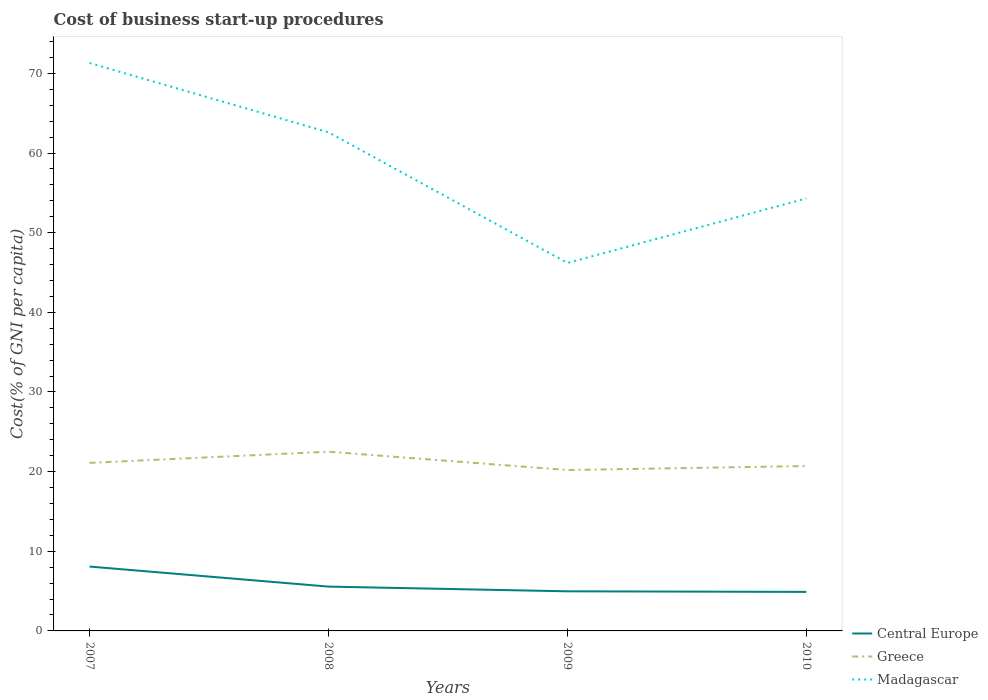Does the line corresponding to Greece intersect with the line corresponding to Madagascar?
Offer a very short reply. No. Across all years, what is the maximum cost of business start-up procedures in Central Europe?
Offer a terse response. 4.9. In which year was the cost of business start-up procedures in Madagascar maximum?
Give a very brief answer. 2009. What is the total cost of business start-up procedures in Greece in the graph?
Make the answer very short. 0.4. What is the difference between the highest and the second highest cost of business start-up procedures in Madagascar?
Keep it short and to the point. 25.1. What is the difference between the highest and the lowest cost of business start-up procedures in Central Europe?
Your answer should be very brief. 1. Is the cost of business start-up procedures in Greece strictly greater than the cost of business start-up procedures in Central Europe over the years?
Offer a terse response. No. How many years are there in the graph?
Provide a succinct answer. 4. How are the legend labels stacked?
Keep it short and to the point. Vertical. What is the title of the graph?
Keep it short and to the point. Cost of business start-up procedures. What is the label or title of the X-axis?
Offer a terse response. Years. What is the label or title of the Y-axis?
Provide a short and direct response. Cost(% of GNI per capita). What is the Cost(% of GNI per capita) of Central Europe in 2007?
Your response must be concise. 8.08. What is the Cost(% of GNI per capita) of Greece in 2007?
Offer a terse response. 21.1. What is the Cost(% of GNI per capita) of Madagascar in 2007?
Provide a succinct answer. 71.3. What is the Cost(% of GNI per capita) of Central Europe in 2008?
Keep it short and to the point. 5.56. What is the Cost(% of GNI per capita) in Madagascar in 2008?
Ensure brevity in your answer.  62.6. What is the Cost(% of GNI per capita) of Central Europe in 2009?
Ensure brevity in your answer.  4.97. What is the Cost(% of GNI per capita) of Greece in 2009?
Offer a terse response. 20.2. What is the Cost(% of GNI per capita) in Madagascar in 2009?
Your response must be concise. 46.2. What is the Cost(% of GNI per capita) in Central Europe in 2010?
Your response must be concise. 4.9. What is the Cost(% of GNI per capita) in Greece in 2010?
Provide a succinct answer. 20.7. What is the Cost(% of GNI per capita) in Madagascar in 2010?
Provide a short and direct response. 54.3. Across all years, what is the maximum Cost(% of GNI per capita) in Central Europe?
Your response must be concise. 8.08. Across all years, what is the maximum Cost(% of GNI per capita) of Madagascar?
Give a very brief answer. 71.3. Across all years, what is the minimum Cost(% of GNI per capita) of Greece?
Offer a terse response. 20.2. Across all years, what is the minimum Cost(% of GNI per capita) of Madagascar?
Provide a short and direct response. 46.2. What is the total Cost(% of GNI per capita) of Central Europe in the graph?
Offer a very short reply. 23.52. What is the total Cost(% of GNI per capita) in Greece in the graph?
Ensure brevity in your answer.  84.5. What is the total Cost(% of GNI per capita) of Madagascar in the graph?
Ensure brevity in your answer.  234.4. What is the difference between the Cost(% of GNI per capita) in Central Europe in 2007 and that in 2008?
Make the answer very short. 2.52. What is the difference between the Cost(% of GNI per capita) in Greece in 2007 and that in 2008?
Give a very brief answer. -1.4. What is the difference between the Cost(% of GNI per capita) in Central Europe in 2007 and that in 2009?
Ensure brevity in your answer.  3.11. What is the difference between the Cost(% of GNI per capita) of Greece in 2007 and that in 2009?
Offer a terse response. 0.9. What is the difference between the Cost(% of GNI per capita) of Madagascar in 2007 and that in 2009?
Offer a terse response. 25.1. What is the difference between the Cost(% of GNI per capita) of Central Europe in 2007 and that in 2010?
Offer a terse response. 3.18. What is the difference between the Cost(% of GNI per capita) of Madagascar in 2007 and that in 2010?
Your answer should be very brief. 17. What is the difference between the Cost(% of GNI per capita) of Central Europe in 2008 and that in 2009?
Your response must be concise. 0.59. What is the difference between the Cost(% of GNI per capita) of Greece in 2008 and that in 2009?
Offer a very short reply. 2.3. What is the difference between the Cost(% of GNI per capita) of Madagascar in 2008 and that in 2009?
Keep it short and to the point. 16.4. What is the difference between the Cost(% of GNI per capita) in Central Europe in 2008 and that in 2010?
Give a very brief answer. 0.66. What is the difference between the Cost(% of GNI per capita) of Central Europe in 2009 and that in 2010?
Give a very brief answer. 0.07. What is the difference between the Cost(% of GNI per capita) of Madagascar in 2009 and that in 2010?
Give a very brief answer. -8.1. What is the difference between the Cost(% of GNI per capita) of Central Europe in 2007 and the Cost(% of GNI per capita) of Greece in 2008?
Your answer should be very brief. -14.42. What is the difference between the Cost(% of GNI per capita) in Central Europe in 2007 and the Cost(% of GNI per capita) in Madagascar in 2008?
Offer a terse response. -54.52. What is the difference between the Cost(% of GNI per capita) of Greece in 2007 and the Cost(% of GNI per capita) of Madagascar in 2008?
Keep it short and to the point. -41.5. What is the difference between the Cost(% of GNI per capita) in Central Europe in 2007 and the Cost(% of GNI per capita) in Greece in 2009?
Give a very brief answer. -12.12. What is the difference between the Cost(% of GNI per capita) of Central Europe in 2007 and the Cost(% of GNI per capita) of Madagascar in 2009?
Ensure brevity in your answer.  -38.12. What is the difference between the Cost(% of GNI per capita) in Greece in 2007 and the Cost(% of GNI per capita) in Madagascar in 2009?
Make the answer very short. -25.1. What is the difference between the Cost(% of GNI per capita) in Central Europe in 2007 and the Cost(% of GNI per capita) in Greece in 2010?
Your answer should be compact. -12.62. What is the difference between the Cost(% of GNI per capita) of Central Europe in 2007 and the Cost(% of GNI per capita) of Madagascar in 2010?
Provide a succinct answer. -46.22. What is the difference between the Cost(% of GNI per capita) of Greece in 2007 and the Cost(% of GNI per capita) of Madagascar in 2010?
Offer a terse response. -33.2. What is the difference between the Cost(% of GNI per capita) in Central Europe in 2008 and the Cost(% of GNI per capita) in Greece in 2009?
Your answer should be compact. -14.64. What is the difference between the Cost(% of GNI per capita) in Central Europe in 2008 and the Cost(% of GNI per capita) in Madagascar in 2009?
Provide a short and direct response. -40.64. What is the difference between the Cost(% of GNI per capita) of Greece in 2008 and the Cost(% of GNI per capita) of Madagascar in 2009?
Keep it short and to the point. -23.7. What is the difference between the Cost(% of GNI per capita) in Central Europe in 2008 and the Cost(% of GNI per capita) in Greece in 2010?
Your answer should be compact. -15.14. What is the difference between the Cost(% of GNI per capita) in Central Europe in 2008 and the Cost(% of GNI per capita) in Madagascar in 2010?
Your answer should be compact. -48.74. What is the difference between the Cost(% of GNI per capita) in Greece in 2008 and the Cost(% of GNI per capita) in Madagascar in 2010?
Offer a terse response. -31.8. What is the difference between the Cost(% of GNI per capita) in Central Europe in 2009 and the Cost(% of GNI per capita) in Greece in 2010?
Your answer should be compact. -15.73. What is the difference between the Cost(% of GNI per capita) in Central Europe in 2009 and the Cost(% of GNI per capita) in Madagascar in 2010?
Make the answer very short. -49.33. What is the difference between the Cost(% of GNI per capita) in Greece in 2009 and the Cost(% of GNI per capita) in Madagascar in 2010?
Provide a succinct answer. -34.1. What is the average Cost(% of GNI per capita) of Central Europe per year?
Offer a terse response. 5.88. What is the average Cost(% of GNI per capita) in Greece per year?
Offer a terse response. 21.12. What is the average Cost(% of GNI per capita) in Madagascar per year?
Your response must be concise. 58.6. In the year 2007, what is the difference between the Cost(% of GNI per capita) of Central Europe and Cost(% of GNI per capita) of Greece?
Offer a terse response. -13.02. In the year 2007, what is the difference between the Cost(% of GNI per capita) in Central Europe and Cost(% of GNI per capita) in Madagascar?
Offer a very short reply. -63.22. In the year 2007, what is the difference between the Cost(% of GNI per capita) of Greece and Cost(% of GNI per capita) of Madagascar?
Offer a terse response. -50.2. In the year 2008, what is the difference between the Cost(% of GNI per capita) in Central Europe and Cost(% of GNI per capita) in Greece?
Make the answer very short. -16.94. In the year 2008, what is the difference between the Cost(% of GNI per capita) in Central Europe and Cost(% of GNI per capita) in Madagascar?
Ensure brevity in your answer.  -57.04. In the year 2008, what is the difference between the Cost(% of GNI per capita) in Greece and Cost(% of GNI per capita) in Madagascar?
Give a very brief answer. -40.1. In the year 2009, what is the difference between the Cost(% of GNI per capita) of Central Europe and Cost(% of GNI per capita) of Greece?
Your response must be concise. -15.23. In the year 2009, what is the difference between the Cost(% of GNI per capita) of Central Europe and Cost(% of GNI per capita) of Madagascar?
Make the answer very short. -41.23. In the year 2009, what is the difference between the Cost(% of GNI per capita) of Greece and Cost(% of GNI per capita) of Madagascar?
Your answer should be compact. -26. In the year 2010, what is the difference between the Cost(% of GNI per capita) in Central Europe and Cost(% of GNI per capita) in Greece?
Offer a terse response. -15.8. In the year 2010, what is the difference between the Cost(% of GNI per capita) in Central Europe and Cost(% of GNI per capita) in Madagascar?
Your answer should be compact. -49.4. In the year 2010, what is the difference between the Cost(% of GNI per capita) in Greece and Cost(% of GNI per capita) in Madagascar?
Offer a terse response. -33.6. What is the ratio of the Cost(% of GNI per capita) of Central Europe in 2007 to that in 2008?
Provide a short and direct response. 1.45. What is the ratio of the Cost(% of GNI per capita) of Greece in 2007 to that in 2008?
Offer a terse response. 0.94. What is the ratio of the Cost(% of GNI per capita) of Madagascar in 2007 to that in 2008?
Your response must be concise. 1.14. What is the ratio of the Cost(% of GNI per capita) of Central Europe in 2007 to that in 2009?
Provide a short and direct response. 1.63. What is the ratio of the Cost(% of GNI per capita) of Greece in 2007 to that in 2009?
Make the answer very short. 1.04. What is the ratio of the Cost(% of GNI per capita) of Madagascar in 2007 to that in 2009?
Offer a terse response. 1.54. What is the ratio of the Cost(% of GNI per capita) in Central Europe in 2007 to that in 2010?
Give a very brief answer. 1.65. What is the ratio of the Cost(% of GNI per capita) of Greece in 2007 to that in 2010?
Ensure brevity in your answer.  1.02. What is the ratio of the Cost(% of GNI per capita) in Madagascar in 2007 to that in 2010?
Offer a very short reply. 1.31. What is the ratio of the Cost(% of GNI per capita) in Central Europe in 2008 to that in 2009?
Offer a terse response. 1.12. What is the ratio of the Cost(% of GNI per capita) in Greece in 2008 to that in 2009?
Your response must be concise. 1.11. What is the ratio of the Cost(% of GNI per capita) in Madagascar in 2008 to that in 2009?
Provide a short and direct response. 1.35. What is the ratio of the Cost(% of GNI per capita) of Central Europe in 2008 to that in 2010?
Your answer should be very brief. 1.14. What is the ratio of the Cost(% of GNI per capita) in Greece in 2008 to that in 2010?
Your answer should be compact. 1.09. What is the ratio of the Cost(% of GNI per capita) of Madagascar in 2008 to that in 2010?
Offer a very short reply. 1.15. What is the ratio of the Cost(% of GNI per capita) of Central Europe in 2009 to that in 2010?
Offer a very short reply. 1.01. What is the ratio of the Cost(% of GNI per capita) of Greece in 2009 to that in 2010?
Offer a very short reply. 0.98. What is the ratio of the Cost(% of GNI per capita) in Madagascar in 2009 to that in 2010?
Offer a very short reply. 0.85. What is the difference between the highest and the second highest Cost(% of GNI per capita) of Central Europe?
Make the answer very short. 2.52. What is the difference between the highest and the second highest Cost(% of GNI per capita) of Greece?
Your answer should be very brief. 1.4. What is the difference between the highest and the second highest Cost(% of GNI per capita) in Madagascar?
Ensure brevity in your answer.  8.7. What is the difference between the highest and the lowest Cost(% of GNI per capita) in Central Europe?
Your answer should be very brief. 3.18. What is the difference between the highest and the lowest Cost(% of GNI per capita) in Greece?
Your answer should be very brief. 2.3. What is the difference between the highest and the lowest Cost(% of GNI per capita) in Madagascar?
Your answer should be very brief. 25.1. 